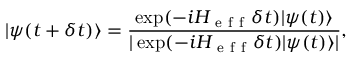Convert formula to latex. <formula><loc_0><loc_0><loc_500><loc_500>| \psi ( t + \delta t ) \rangle = \frac { \exp ( - i H _ { e f f } \delta t ) | \psi ( t ) \rangle } { | \exp ( - i H _ { e f f } \delta t ) | \psi ( t ) \rangle | } ,</formula> 